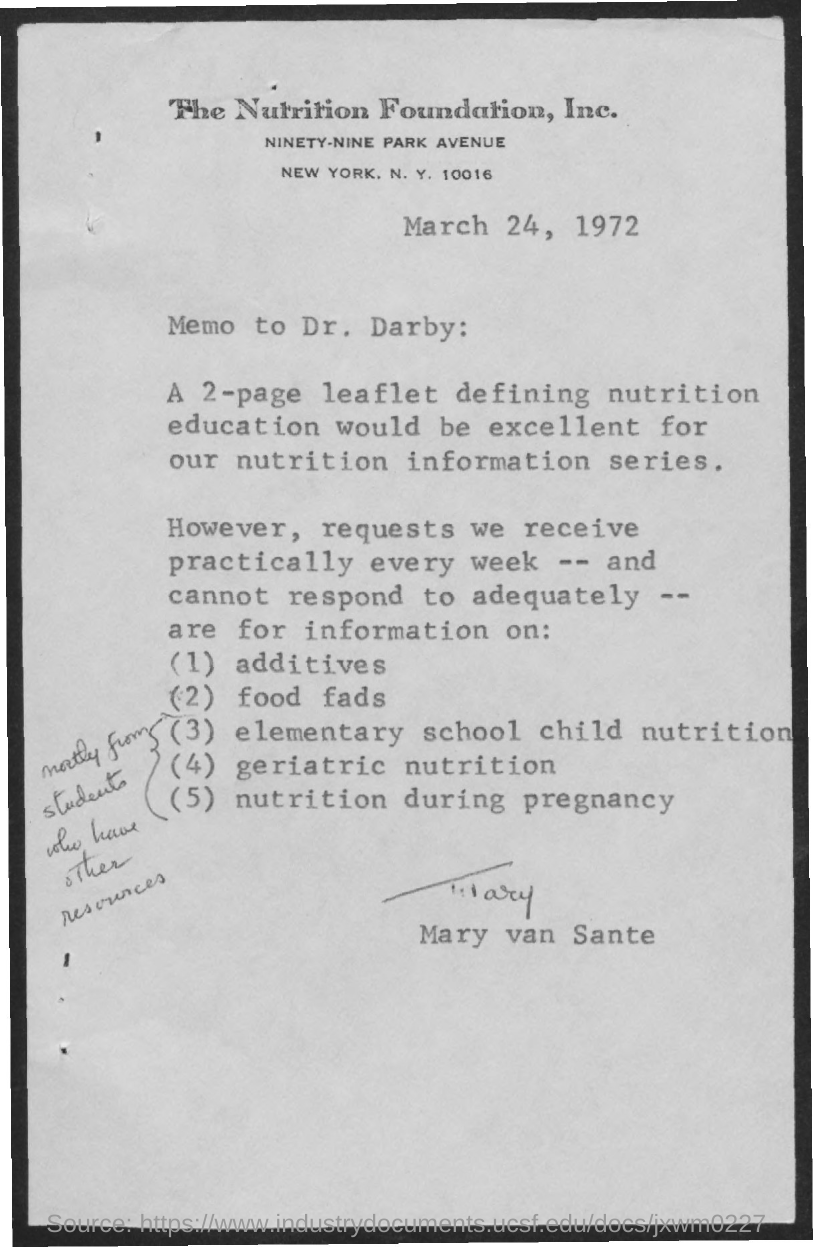Specify some key components in this picture. Mary sent the memo to Dr. Darby. The memo was sent by Mary van Sante. 